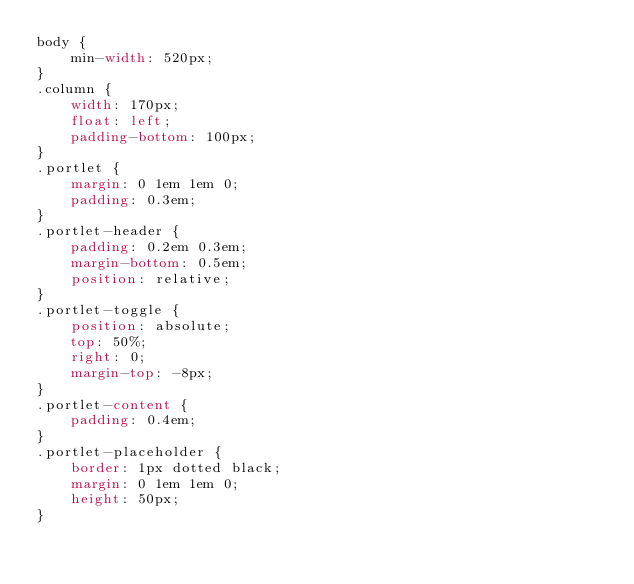<code> <loc_0><loc_0><loc_500><loc_500><_CSS_>body {
    min-width: 520px;
}
.column {
    width: 170px;
    float: left;
    padding-bottom: 100px;
}
.portlet {
    margin: 0 1em 1em 0;
    padding: 0.3em;
}
.portlet-header {
    padding: 0.2em 0.3em;
    margin-bottom: 0.5em;
    position: relative;
}
.portlet-toggle {
    position: absolute;
    top: 50%;
    right: 0;
    margin-top: -8px;
}
.portlet-content {
    padding: 0.4em;
}
.portlet-placeholder {
    border: 1px dotted black;
    margin: 0 1em 1em 0;
    height: 50px;
}</code> 